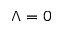Convert formula to latex. <formula><loc_0><loc_0><loc_500><loc_500>\Lambda = 0</formula> 